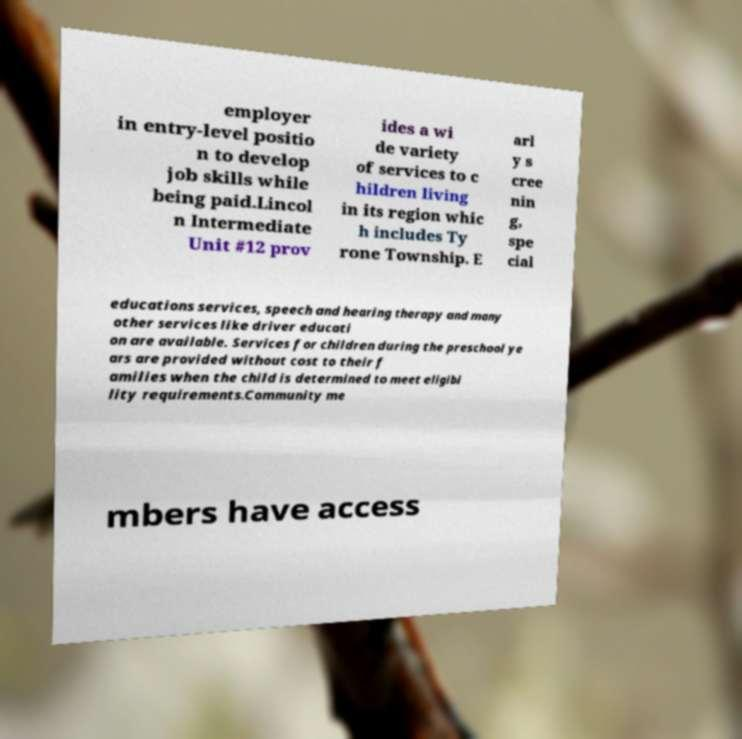Can you accurately transcribe the text from the provided image for me? employer in entry-level positio n to develop job skills while being paid.Lincol n Intermediate Unit #12 prov ides a wi de variety of services to c hildren living in its region whic h includes Ty rone Township. E arl y s cree nin g, spe cial educations services, speech and hearing therapy and many other services like driver educati on are available. Services for children during the preschool ye ars are provided without cost to their f amilies when the child is determined to meet eligibi lity requirements.Community me mbers have access 